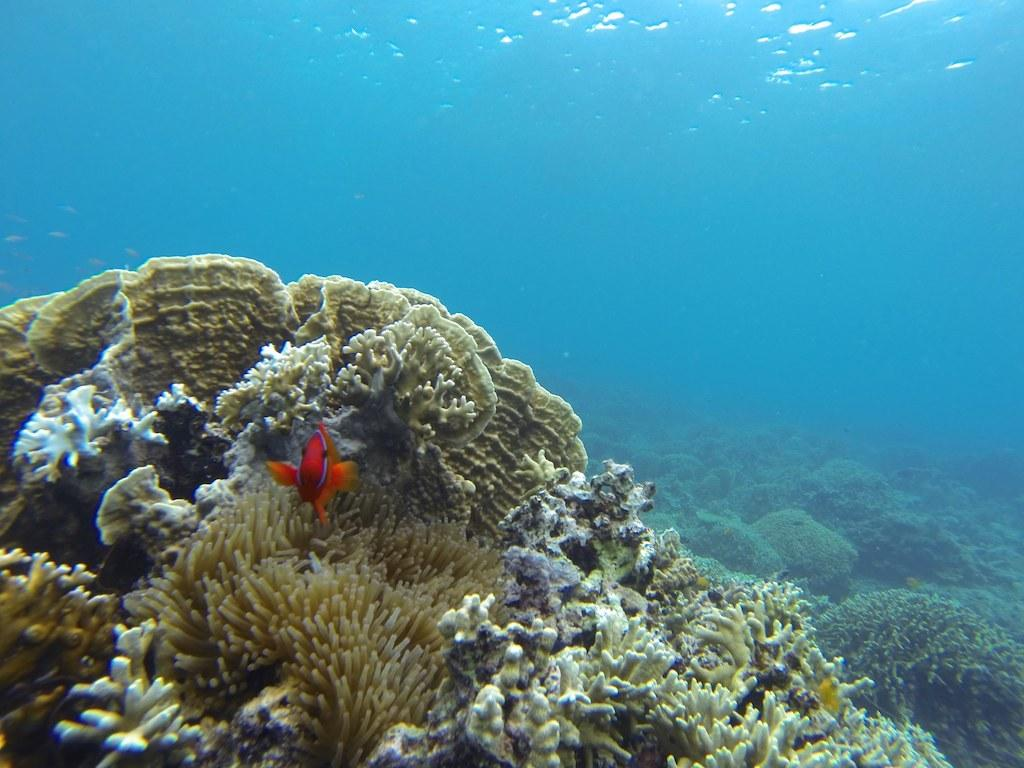What is the main subject in the foreground of the image? There is a red fish in the foreground of the image. What can be seen in the background of the image? There are sea plants visible in the background of the image. Are the sea plants located above or below the water's surface? The sea plants are underwater. How many gloves can be seen in the image? There are no gloves present in the image. What type of mice are swimming with the red fish in the image? There are no mice present in the image; it features a red fish and sea plants. 